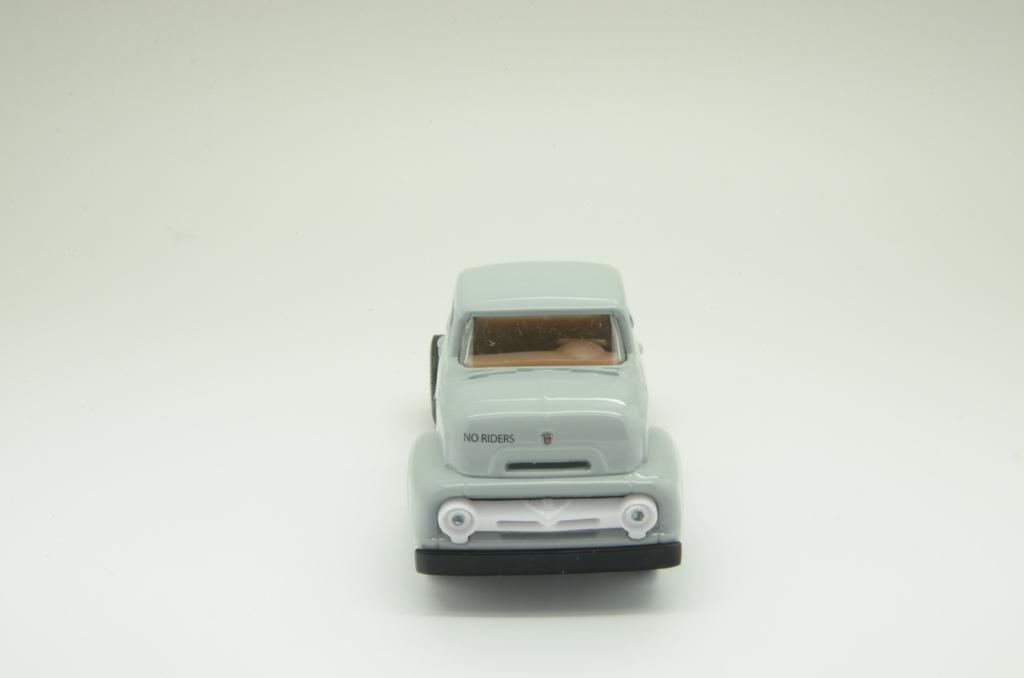What is the main object in the image? There is a toy car in the image. What color is the background of the image? The background of the image is white. What place does the toy car visit in the image? The image does not depict the toy car visiting any specific place. Does the toy car cry in the image? Toys, including toy cars, do not have the ability to cry, so this cannot be observed in the image. 